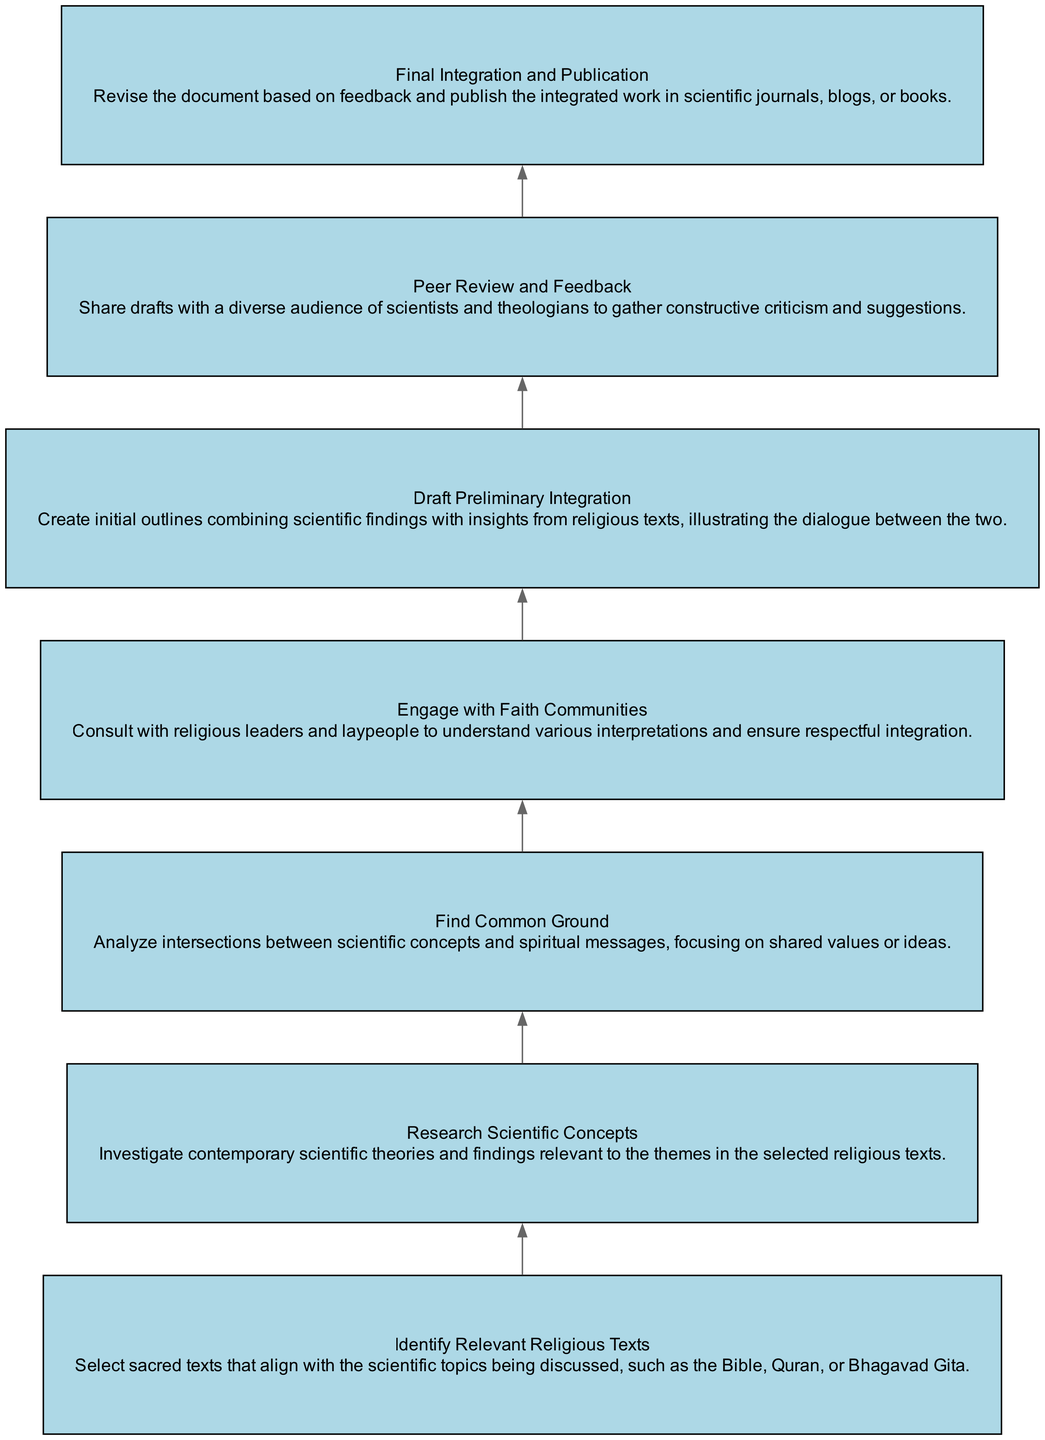What is the first step in the process? The first step is "Identify Relevant Religious Texts," which is the top node in the flow chart.
Answer: Identify Relevant Religious Texts How many total nodes are in the diagram? There are seven nodes present in the diagram that represent different steps in the integration process.
Answer: 7 Which step follows "Find Common Ground"? The step that follows "Find Common Ground" is "Engage with Faith Communities," as the nodes are connected in a bottom-up flow.
Answer: Engage with Faith Communities What is the last step before "Final Integration and Publication"? The step before "Final Integration and Publication" is "Peer Review and Feedback," indicating a critical appraisal stage before the final revision.
Answer: Peer Review and Feedback How many edges connect the nodes in the diagram? There are six edges that connect the seven nodes, showing the flow between each process step.
Answer: 6 What does the "Draft Preliminary Integration" step involve? This step involves creating initial outlines that combine scientific findings with insights from religious texts, highlighting the dialogue between them.
Answer: Create initial outlines What is the relationship between "Research Scientific Concepts" and "Find Common Ground"? "Research Scientific Concepts" precedes "Find Common Ground," indicating that understanding scientific concepts is necessary to analyze intersections with spirituality.
Answer: Precedes What does "Engage with Faith Communities" aim to achieve? This step aims to consult with religious leaders and laypeople to ensure respectful integration and various interpretations are understood.
Answer: Ensure respectful integration What is the purpose of the "Peer Review and Feedback" step? The purpose is to share drafts with a diverse audience to gather constructive criticism and improve the work based on suggestions.
Answer: Gather constructive criticism 